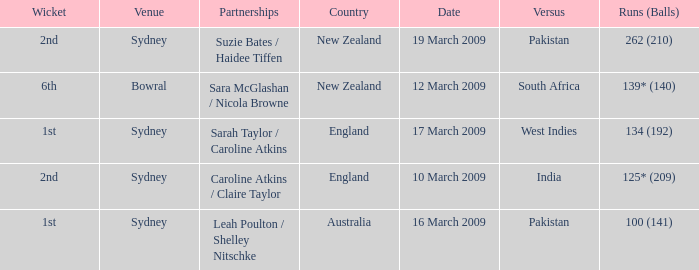What are the dates where the versus team is South Africa? 12 March 2009. 